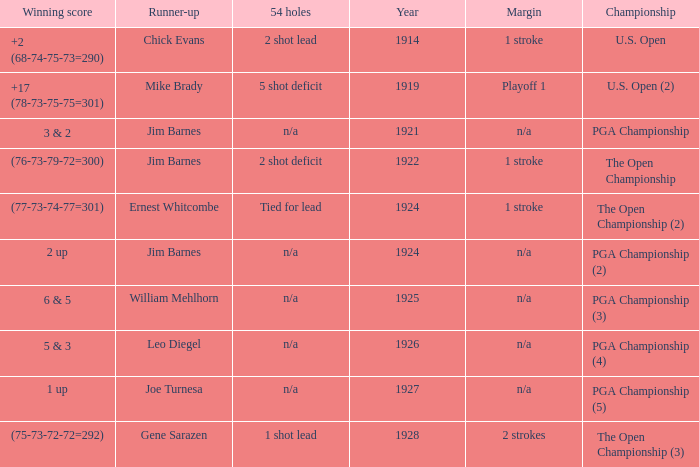WHAT YEAR WAS IT WHEN THE SCORE WAS 3 & 2? 1921.0. Parse the full table. {'header': ['Winning score', 'Runner-up', '54 holes', 'Year', 'Margin', 'Championship'], 'rows': [['+2 (68-74-75-73=290)', 'Chick Evans', '2 shot lead', '1914', '1 stroke', 'U.S. Open'], ['+17 (78-73-75-75=301)', 'Mike Brady', '5 shot deficit', '1919', 'Playoff 1', 'U.S. Open (2)'], ['3 & 2', 'Jim Barnes', 'n/a', '1921', 'n/a', 'PGA Championship'], ['(76-73-79-72=300)', 'Jim Barnes', '2 shot deficit', '1922', '1 stroke', 'The Open Championship'], ['(77-73-74-77=301)', 'Ernest Whitcombe', 'Tied for lead', '1924', '1 stroke', 'The Open Championship (2)'], ['2 up', 'Jim Barnes', 'n/a', '1924', 'n/a', 'PGA Championship (2)'], ['6 & 5', 'William Mehlhorn', 'n/a', '1925', 'n/a', 'PGA Championship (3)'], ['5 & 3', 'Leo Diegel', 'n/a', '1926', 'n/a', 'PGA Championship (4)'], ['1 up', 'Joe Turnesa', 'n/a', '1927', 'n/a', 'PGA Championship (5)'], ['(75-73-72-72=292)', 'Gene Sarazen', '1 shot lead', '1928', '2 strokes', 'The Open Championship (3)']]} 